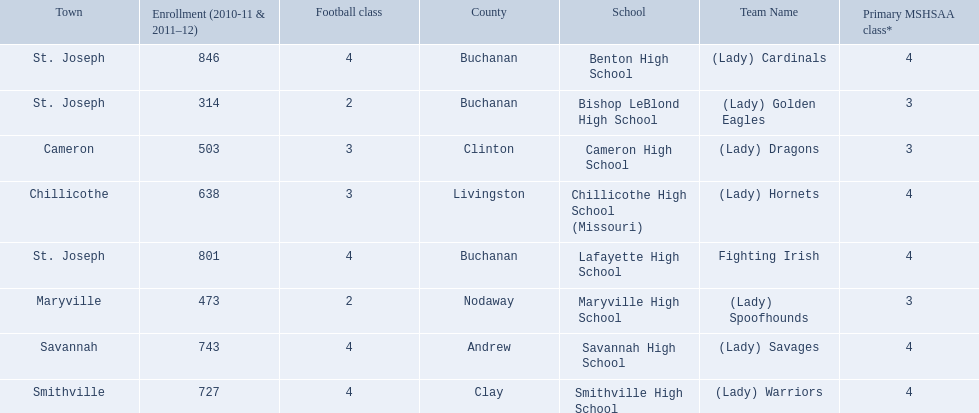What schools are located in st. joseph? Benton High School, Bishop LeBlond High School, Lafayette High School. Which st. joseph schools have more then 800 enrollment  for 2010-11 7 2011-12? Benton High School, Lafayette High School. What is the name of the st. joseph school with 800 or more enrollment's team names is a not a (lady)? Lafayette High School. 